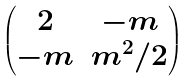<formula> <loc_0><loc_0><loc_500><loc_500>\begin{pmatrix} 2 & - m \\ - m & m ^ { 2 } / 2 \end{pmatrix}</formula> 